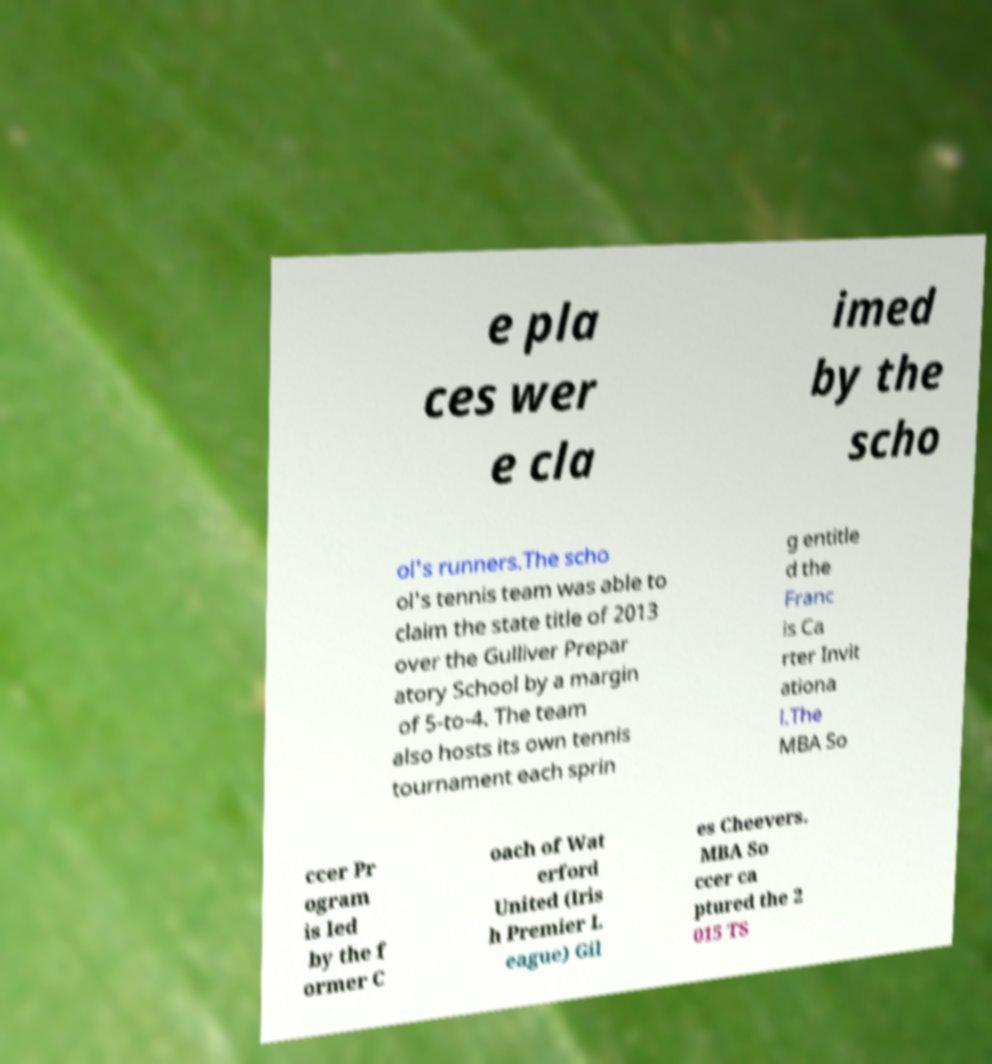Please identify and transcribe the text found in this image. e pla ces wer e cla imed by the scho ol's runners.The scho ol's tennis team was able to claim the state title of 2013 over the Gulliver Prepar atory School by a margin of 5-to-4. The team also hosts its own tennis tournament each sprin g entitle d the Franc is Ca rter Invit ationa l.The MBA So ccer Pr ogram is led by the f ormer C oach of Wat erford United (Iris h Premier L eague) Gil es Cheevers. MBA So ccer ca ptured the 2 015 TS 